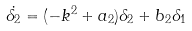Convert formula to latex. <formula><loc_0><loc_0><loc_500><loc_500>\dot { \delta _ { 2 } } = ( - k ^ { 2 } + a _ { 2 } ) \delta _ { 2 } + b _ { 2 } \delta _ { 1 }</formula> 